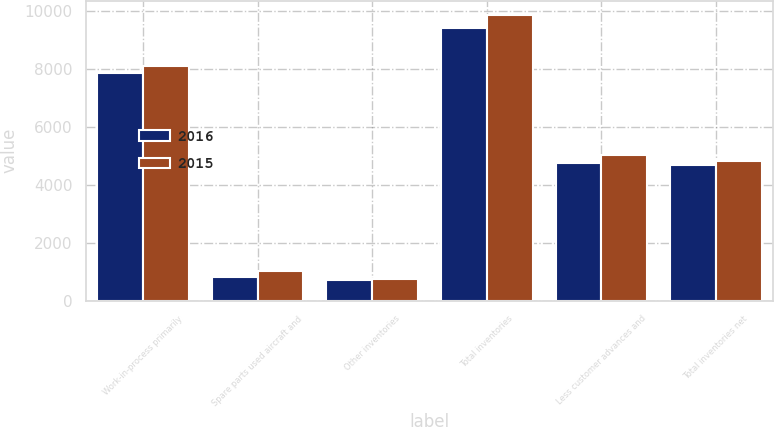Convert chart. <chart><loc_0><loc_0><loc_500><loc_500><stacked_bar_chart><ecel><fcel>Work-in-process primarily<fcel>Spare parts used aircraft and<fcel>Other inventories<fcel>Total inventories<fcel>Less customer advances and<fcel>Total inventories net<nl><fcel>2016<fcel>7864<fcel>833<fcel>719<fcel>9416<fcel>4746<fcel>4670<nl><fcel>2015<fcel>8081<fcel>1030<fcel>740<fcel>9851<fcel>5032<fcel>4819<nl></chart> 